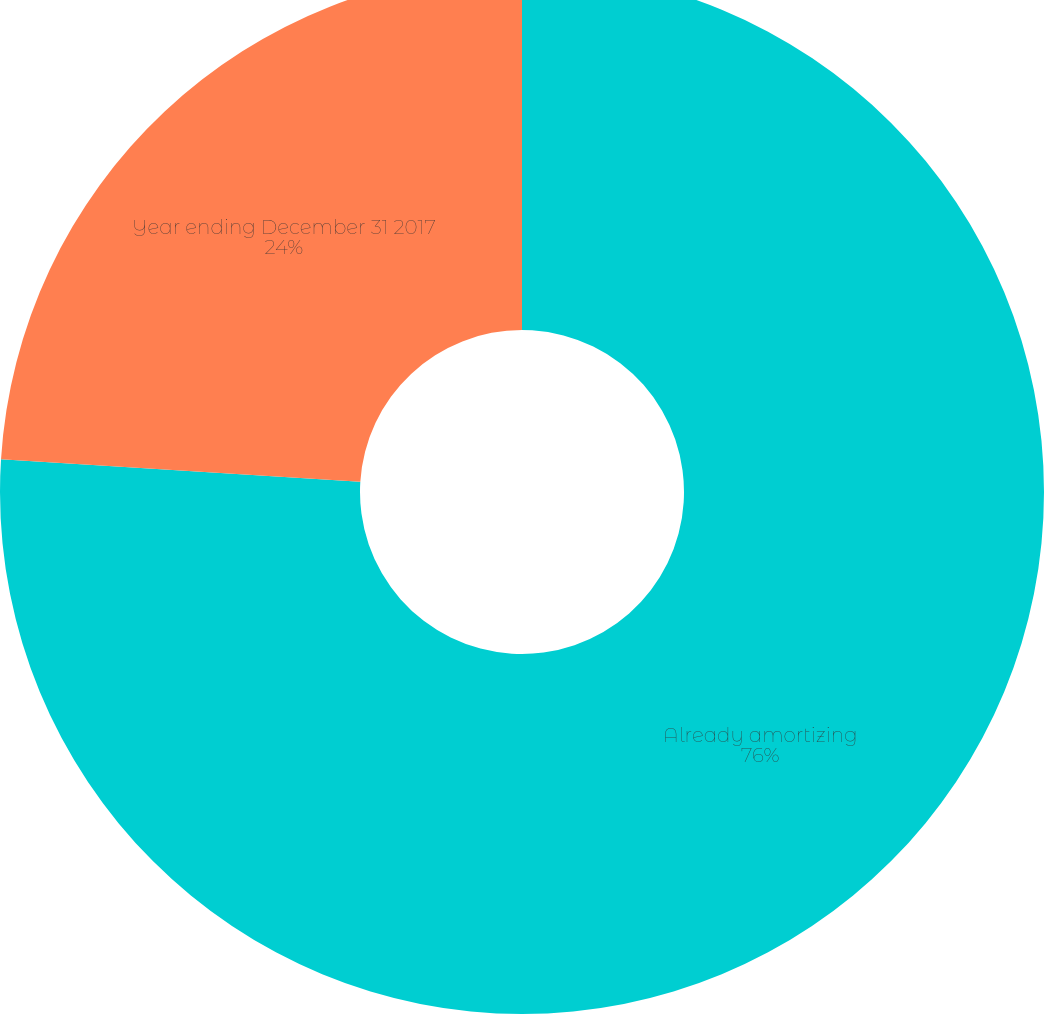<chart> <loc_0><loc_0><loc_500><loc_500><pie_chart><fcel>Already amortizing<fcel>Year ending December 31 2017<nl><fcel>76.0%<fcel>24.0%<nl></chart> 